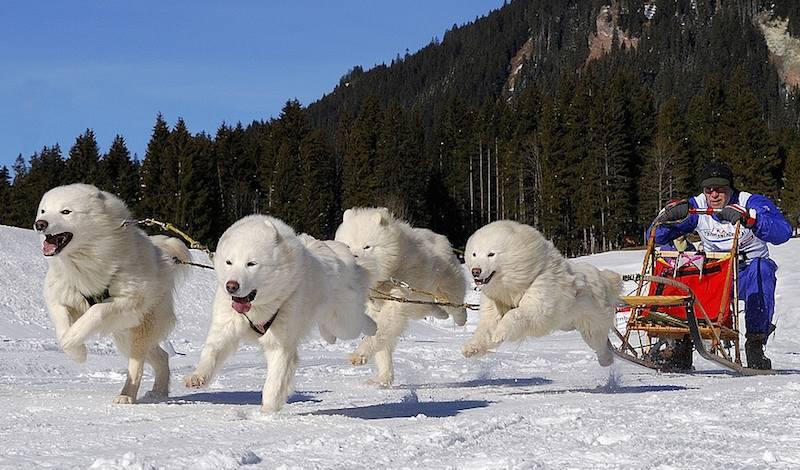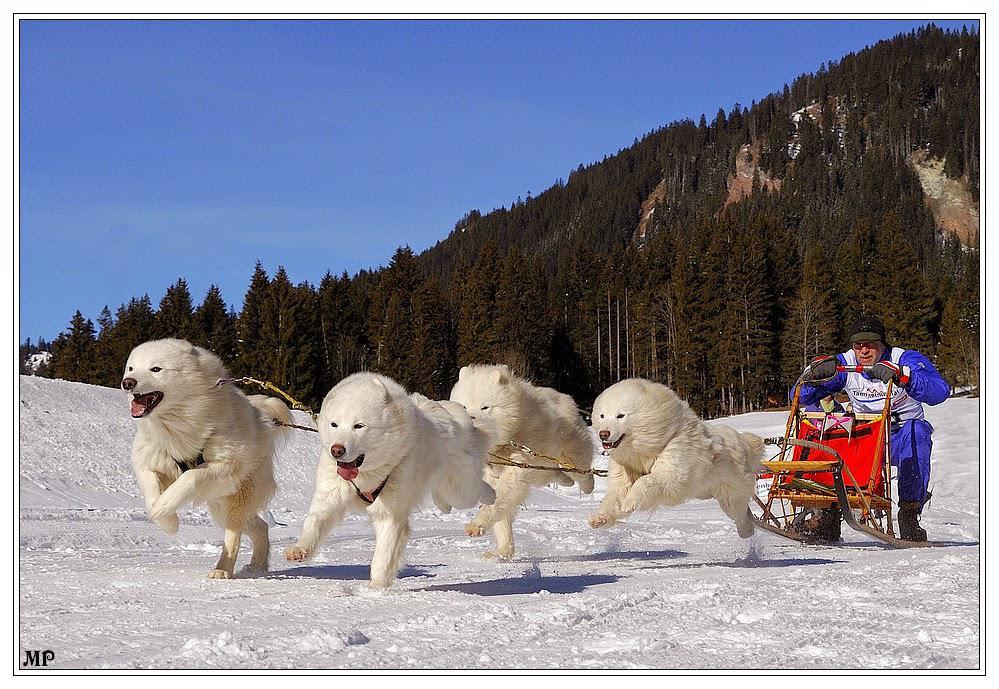The first image is the image on the left, the second image is the image on the right. For the images displayed, is the sentence "There is exactly on dog in the image on the right." factually correct? Answer yes or no. No. 